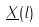<formula> <loc_0><loc_0><loc_500><loc_500>\underline { X } ( l )</formula> 